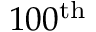<formula> <loc_0><loc_0><loc_500><loc_500>1 0 0 ^ { t h }</formula> 